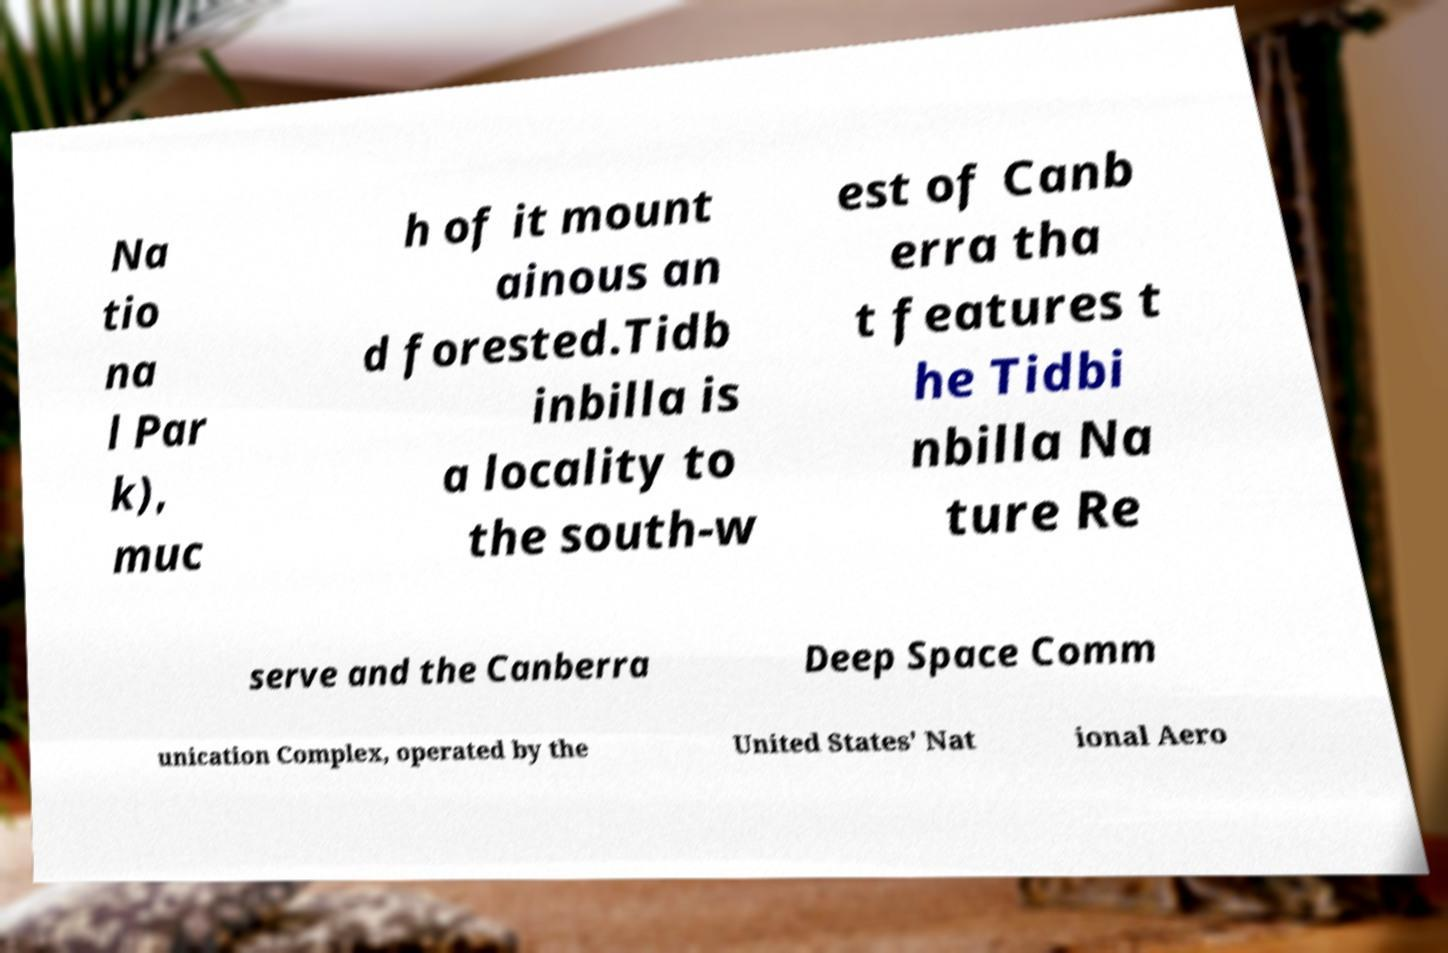There's text embedded in this image that I need extracted. Can you transcribe it verbatim? Na tio na l Par k), muc h of it mount ainous an d forested.Tidb inbilla is a locality to the south-w est of Canb erra tha t features t he Tidbi nbilla Na ture Re serve and the Canberra Deep Space Comm unication Complex, operated by the United States' Nat ional Aero 